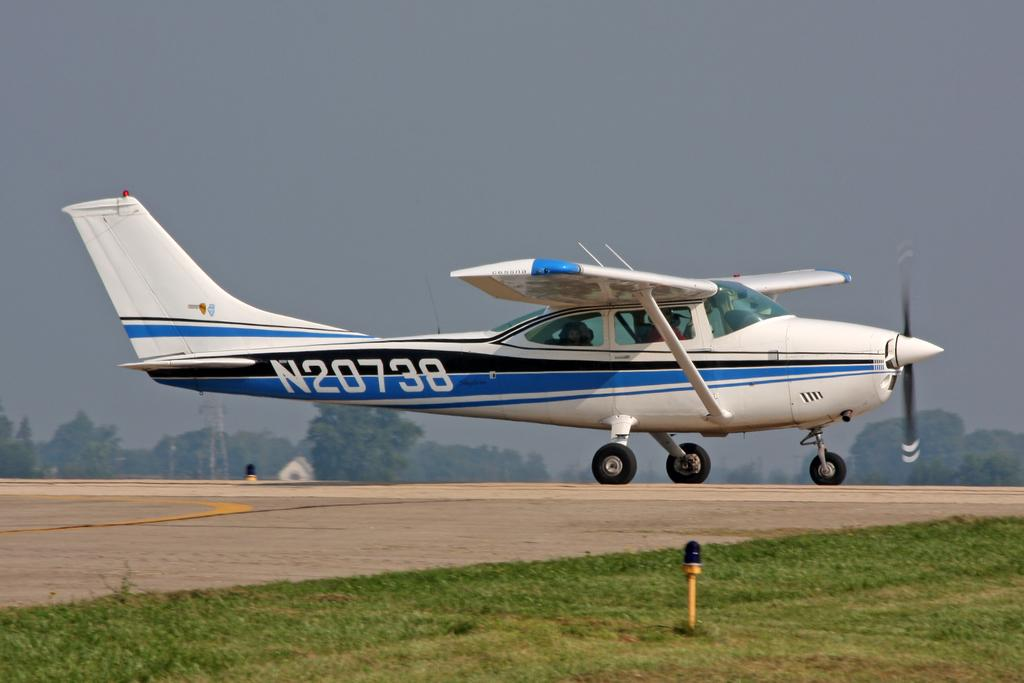Provide a one-sentence caption for the provided image. Plane N20738 which is colored blue, black, and white is coming in for a landing. 